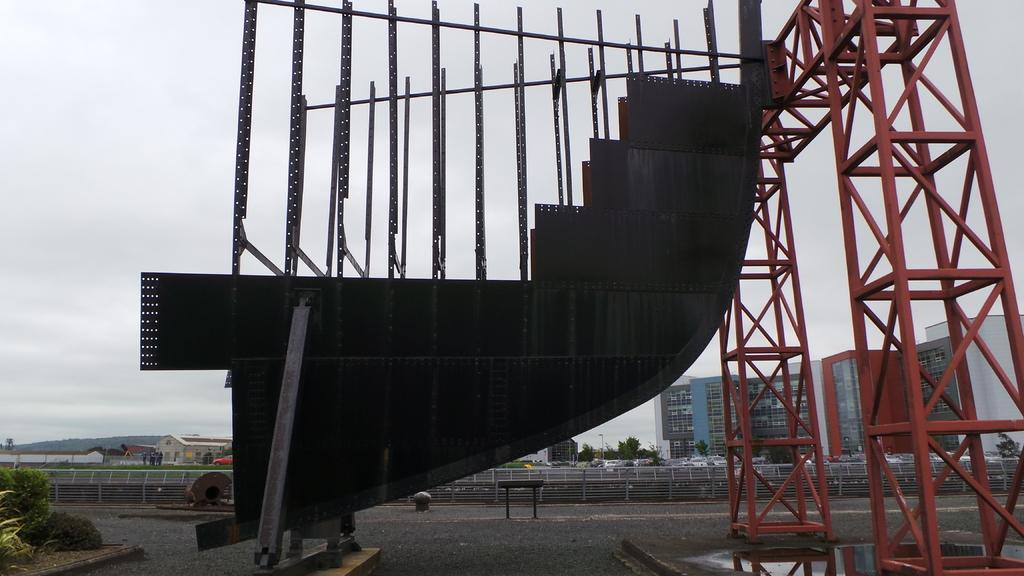What type of poles can be seen in the image? There are ironic poles in the image. What architectural feature is present in the image? There are stairs in the image. What type of vegetation is visible in the image? There are trees in the image. Who or what is present in the image? There are people in the image. What type of structures can be seen in the image? There are buildings in the image. What is visible at the top of the image? The sky is visible at the top of the image. How many copies of the same person can be seen in the image? There are no copies of the same person in the image; each person is unique. What type of transportation is available at the airport in the image? There is no airport present in the image, so no transportation options can be determined. 